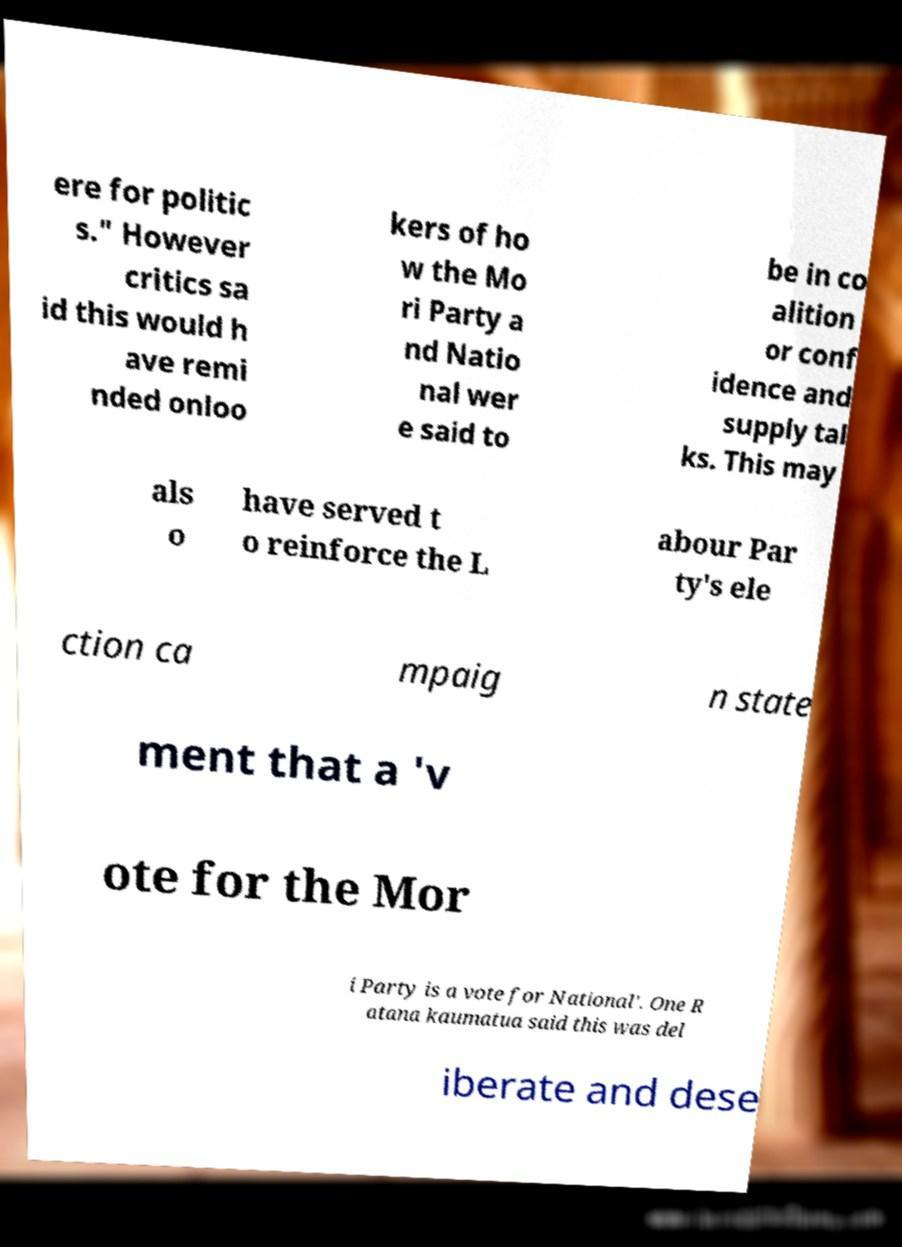Could you assist in decoding the text presented in this image and type it out clearly? ere for politic s." However critics sa id this would h ave remi nded onloo kers of ho w the Mo ri Party a nd Natio nal wer e said to be in co alition or conf idence and supply tal ks. This may als o have served t o reinforce the L abour Par ty's ele ction ca mpaig n state ment that a 'v ote for the Mor i Party is a vote for National'. One R atana kaumatua said this was del iberate and dese 